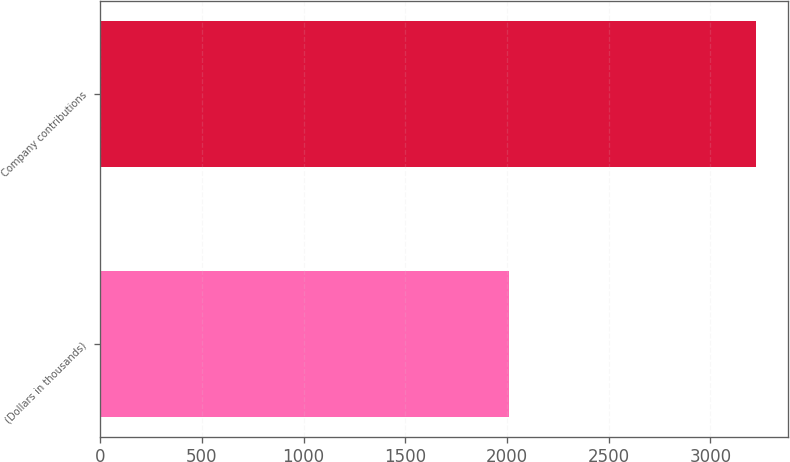<chart> <loc_0><loc_0><loc_500><loc_500><bar_chart><fcel>(Dollars in thousands)<fcel>Company contributions<nl><fcel>2011<fcel>3223<nl></chart> 